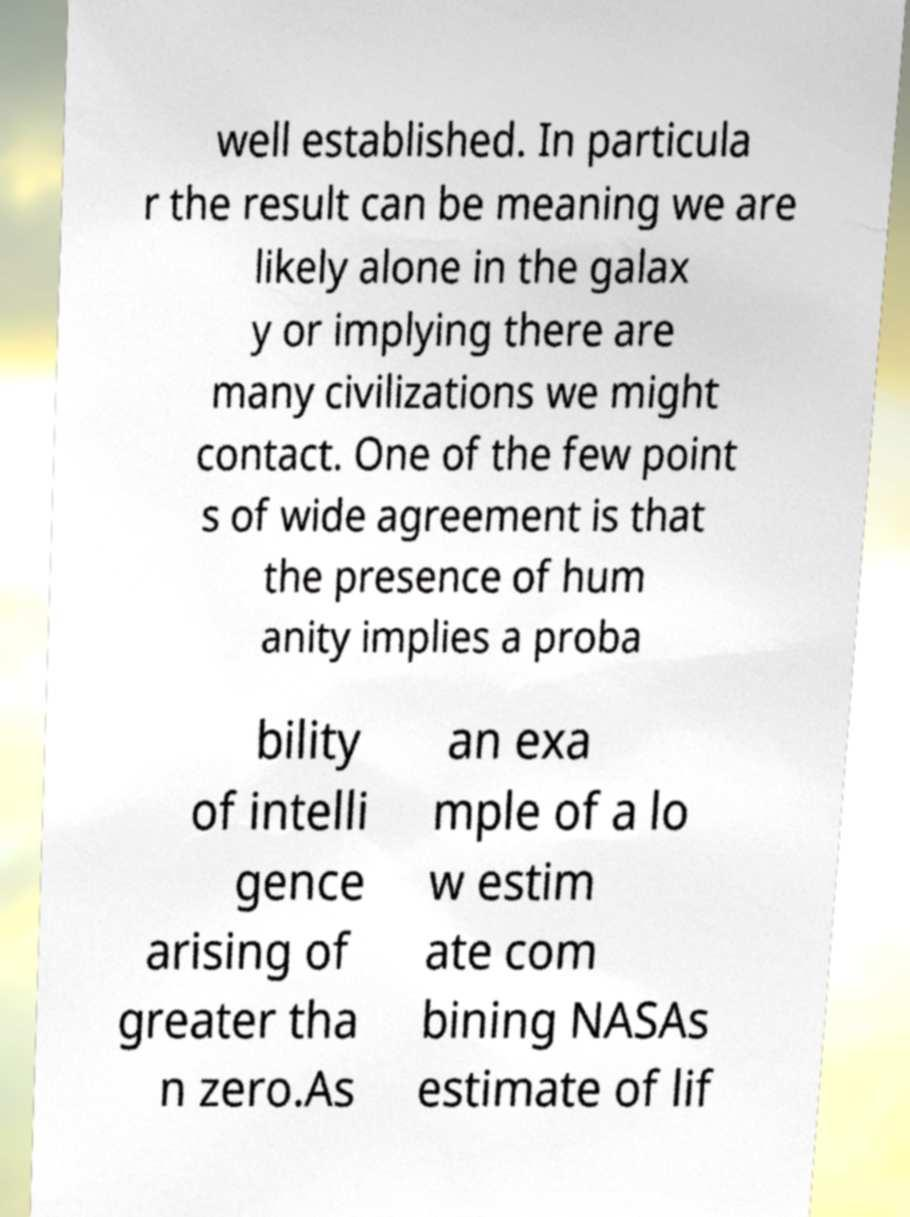Please identify and transcribe the text found in this image. well established. In particula r the result can be meaning we are likely alone in the galax y or implying there are many civilizations we might contact. One of the few point s of wide agreement is that the presence of hum anity implies a proba bility of intelli gence arising of greater tha n zero.As an exa mple of a lo w estim ate com bining NASAs estimate of lif 